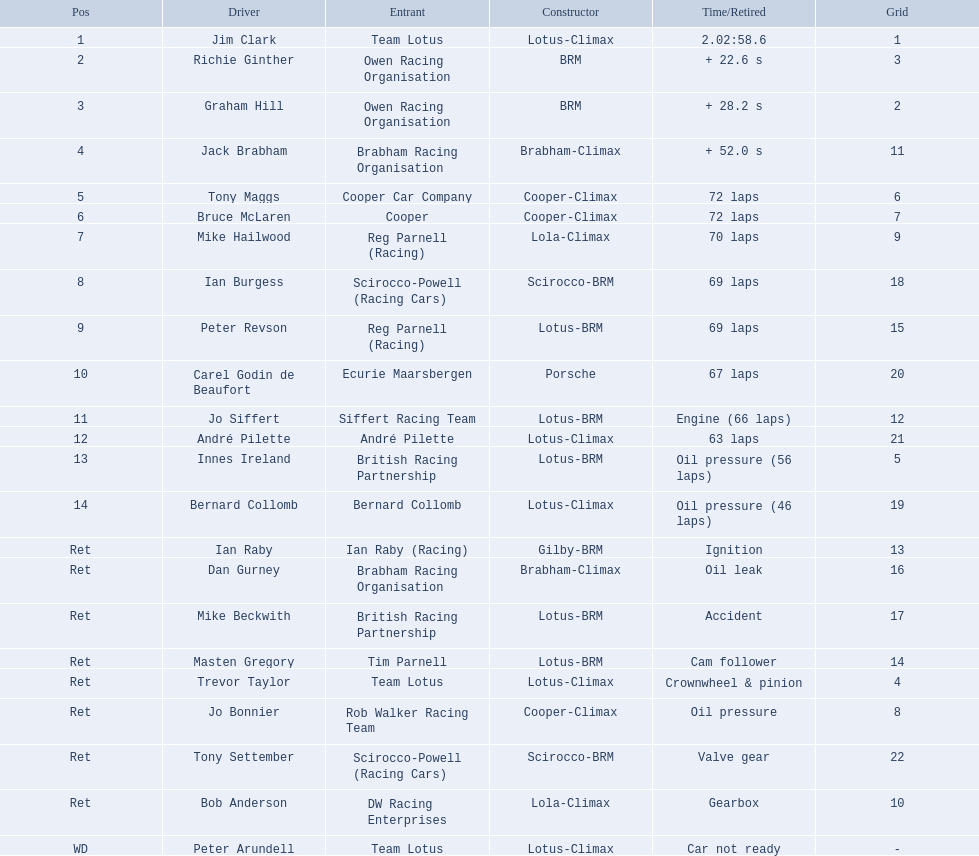Who were the drivers in the the 1963 international gold cup? Jim Clark, Richie Ginther, Graham Hill, Jack Brabham, Tony Maggs, Bruce McLaren, Mike Hailwood, Ian Burgess, Peter Revson, Carel Godin de Beaufort, Jo Siffert, André Pilette, Innes Ireland, Bernard Collomb, Ian Raby, Dan Gurney, Mike Beckwith, Masten Gregory, Trevor Taylor, Jo Bonnier, Tony Settember, Bob Anderson, Peter Arundell. Which drivers drove a cooper-climax car? Tony Maggs, Bruce McLaren, Jo Bonnier. What did these drivers place? 5, 6, Ret. What was the best placing position? 5. Who was the driver with this placing? Tony Maggs. 